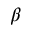<formula> <loc_0><loc_0><loc_500><loc_500>\beta</formula> 